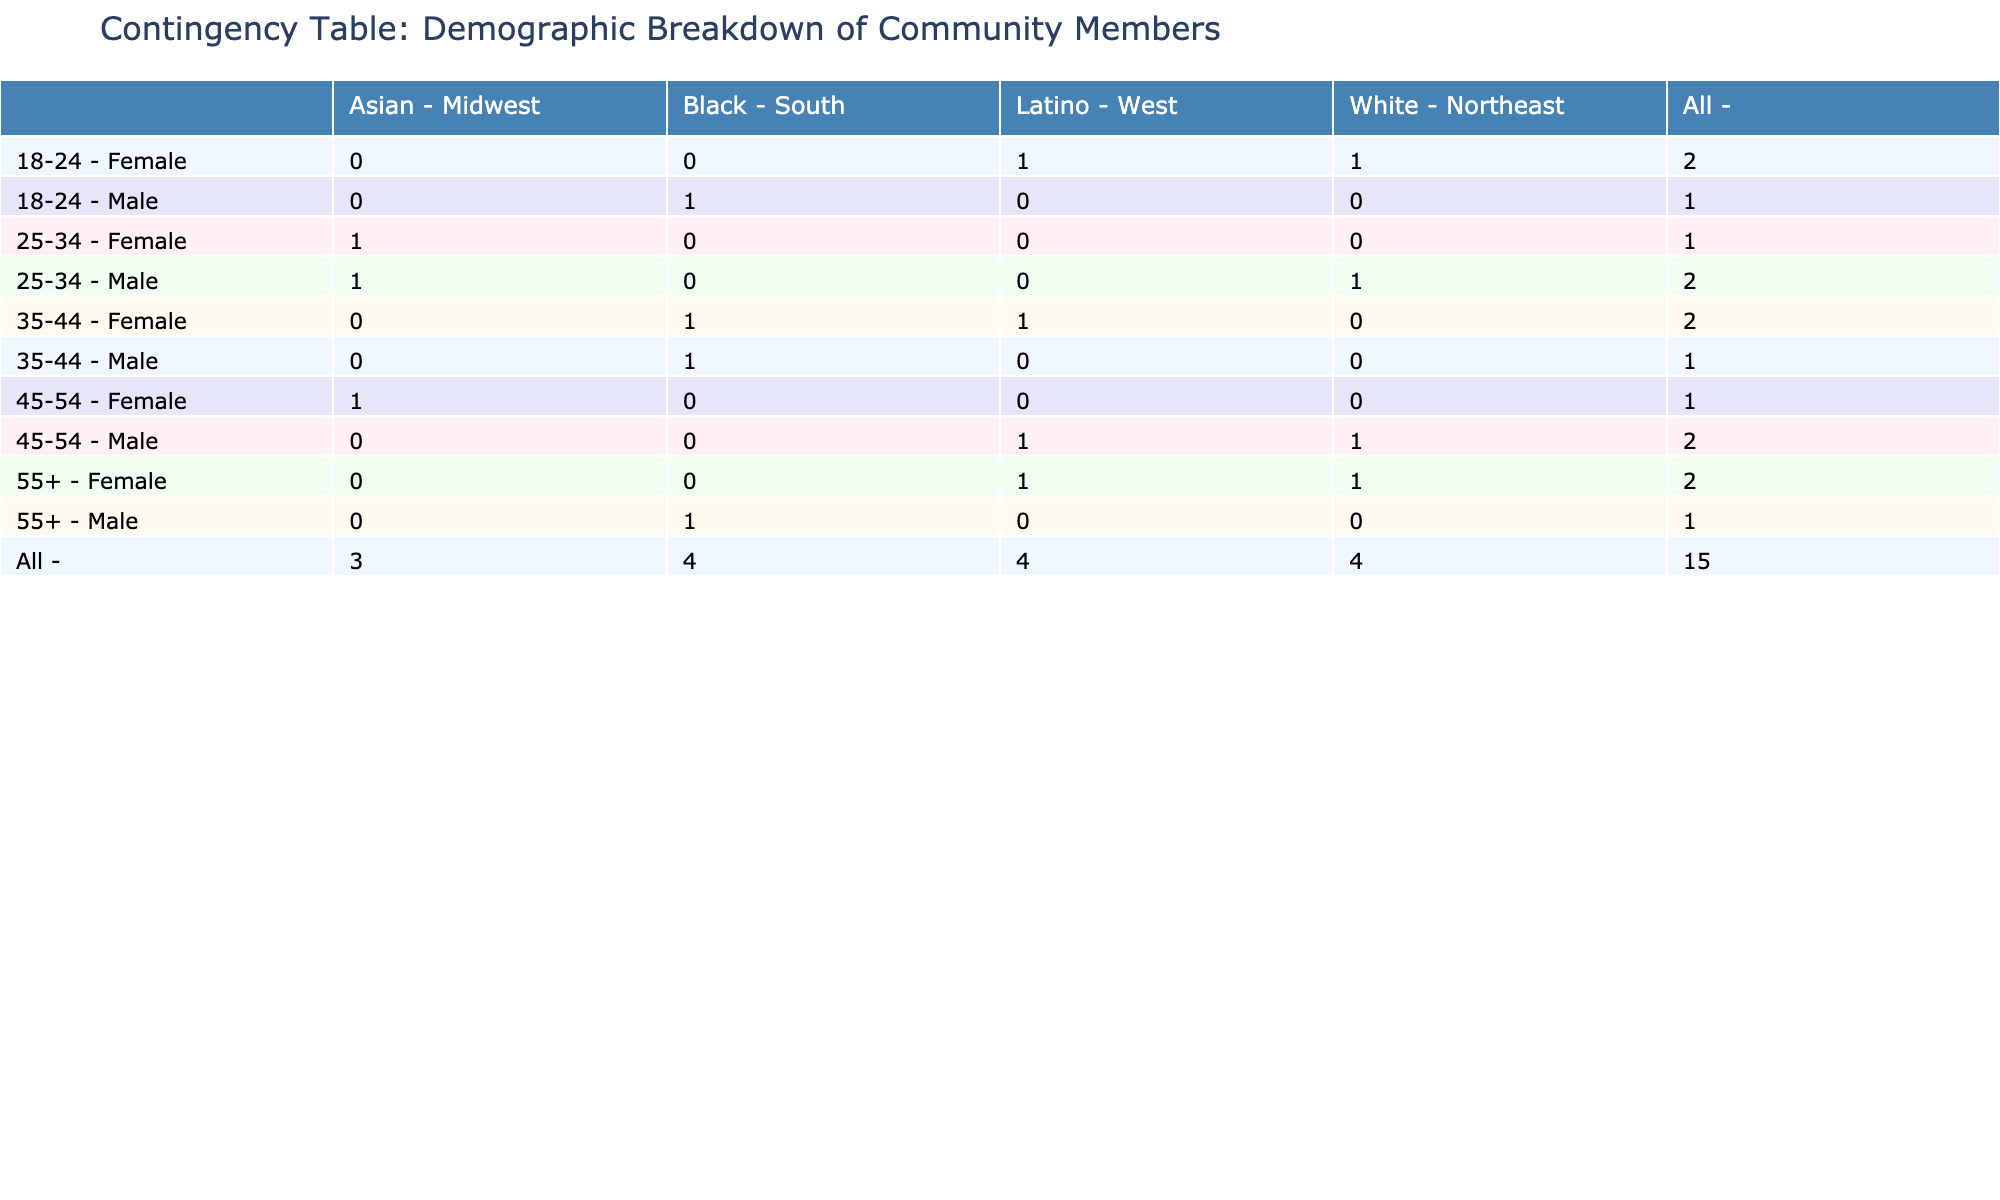What is the highest participation level among Female members aged 35-44? In the table, look for Female members in the age group 35-44. There is one instance of Female Latino with high participation and one instance of Female Black with low participation. The highest participation level recorded for this group is High.
Answer: High How many Male participants are from the South region? To find the number of Male participants from the South region, we can count the entries in the table where the gender is Male and the region is South. The relevant entries are three: Male Black with High participation, Male Black with Medium participation, and Male Black with Medium participation (age 55+). This gives a total of 3 Male participants from the South region.
Answer: 3 Is there any Female participant aged 25-34 with Medium participation? Looking at the table, for Female participants aged 25-34, there is one instance: Female Asian with Low participation. Thus, the answer is no, as there are no Female members in this age bracket with Medium participation.
Answer: No What is the total number of participants aged 55 and over with High participation? We need to identify participants aged 55+ and check their participation levels. The relevant data points show two Female members with High participation (Female Latino and Female White). There are no Male members in this age group with High participation. Therefore, the total number is 2.
Answer: 2 Which age group has the highest number of Male participants with High participation? The age group with the highest number of Male participants with High participation can be determined by checking each relevant section. Only two age groups have Male participants with High participation: 18-24 and 25-34. Both groups have one Male each, but since the 25-34 group also has a High (Male White), it remains a tie in terms of quantity. Thus, both 18-24 and 25-34 share the highest count.
Answer: 18-24 and 25-34 What is the participation level ratio of Females to Males in the 45-54 age group categorized by High and Low? For Females in the 45-54 age group, we have two instances: Female Asian with Medium participation and Female Latino with Medium participation. Males in the same age group have one entry (Male White) with Low participation. The counts lead to Females with Medium (2) against Males with Low (1). Therefore, the ratio of Females to Males in the 45-54 age group is 2:1.
Answer: 2:1 Are there any Female participants from the Northeast region in the 18-24 age group with Medium participation? Reviewing the entries, the only Female participant from the Northeast in the 18-24 age group is Female White, who has High participation. There are no Females from the Northeast in the 18-24 age group with Medium participation as per the observed data.
Answer: No Which ethnicity among 25-34 age group Males shows the highest participation level? For Males in the 25-34 age group, we have one Male White with High participation and one Male Asian with Medium participation. Therefore, the Male White participant has the highest level of participation in that age group.
Answer: White 